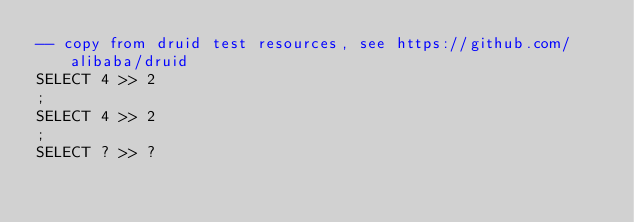<code> <loc_0><loc_0><loc_500><loc_500><_SQL_>-- copy from druid test resources, see https://github.com/alibaba/druid
SELECT 4 >> 2
;
SELECT 4 >> 2
;
SELECT ? >> ?
</code> 